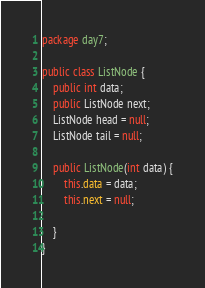Convert code to text. <code><loc_0><loc_0><loc_500><loc_500><_Java_>package day7;

public class ListNode {
    public int data;
    public ListNode next;
    ListNode head = null;
    ListNode tail = null;

    public ListNode(int data) {
        this.data = data;
        this.next = null;

    }
}</code> 